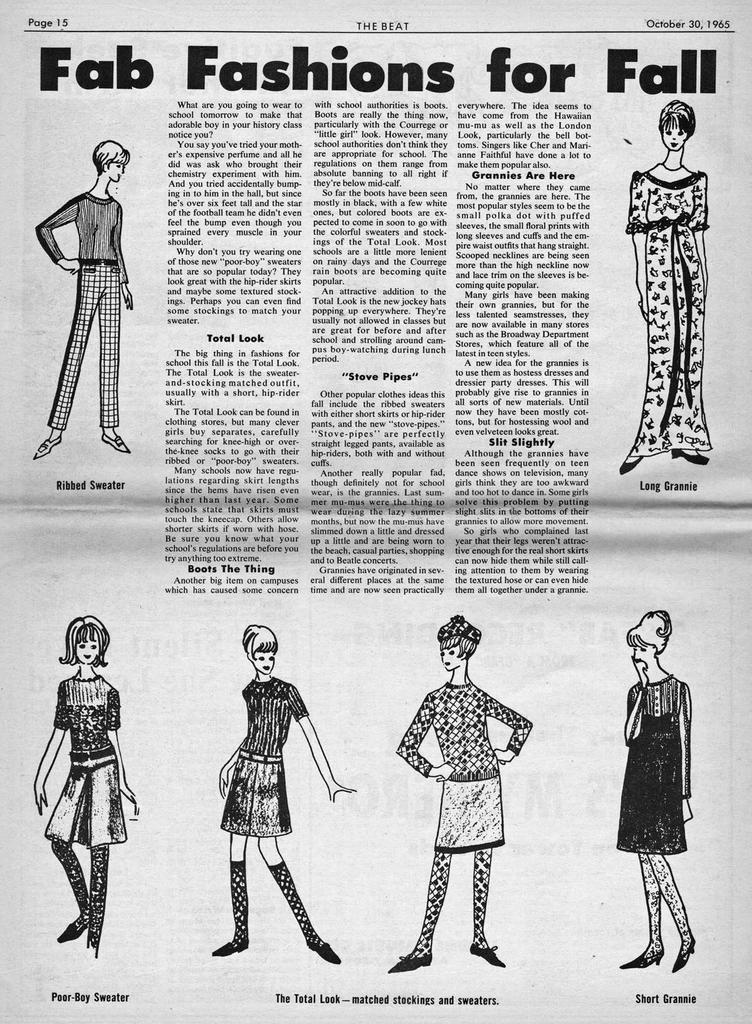What type of images are present in the image? There are cartoon pictures in the image. What else can be seen in the image besides the cartoon pictures? There is text written on paper in the image. What type of whistle is used by the cartoon character in the image? There is no whistle present in the image. Who is the owner of the cartoon character in the image? The image does not provide information about the ownership of the cartoon character. 